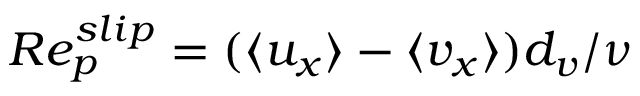Convert formula to latex. <formula><loc_0><loc_0><loc_500><loc_500>R e _ { p } ^ { s l i p } = ( \langle u _ { x } \rangle - \langle v _ { x } \rangle ) d _ { v } / \nu</formula> 